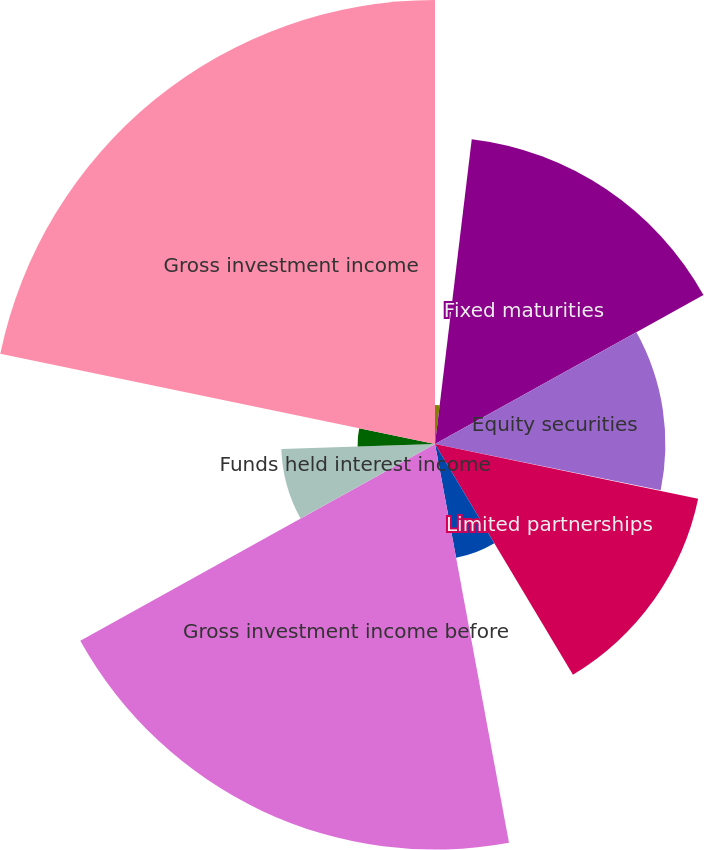Convert chart to OTSL. <chart><loc_0><loc_0><loc_500><loc_500><pie_chart><fcel>(Dollars in thousands)<fcel>Fixed maturities<fcel>Equity securities<fcel>Short-term investments and<fcel>Limited partnerships<fcel>Other<fcel>Gross investment income before<fcel>Funds held interest income<fcel>Future policy benefit reserve<fcel>Gross investment income<nl><fcel>1.91%<fcel>15.03%<fcel>11.28%<fcel>0.04%<fcel>13.16%<fcel>5.66%<fcel>19.86%<fcel>7.53%<fcel>3.79%<fcel>21.74%<nl></chart> 